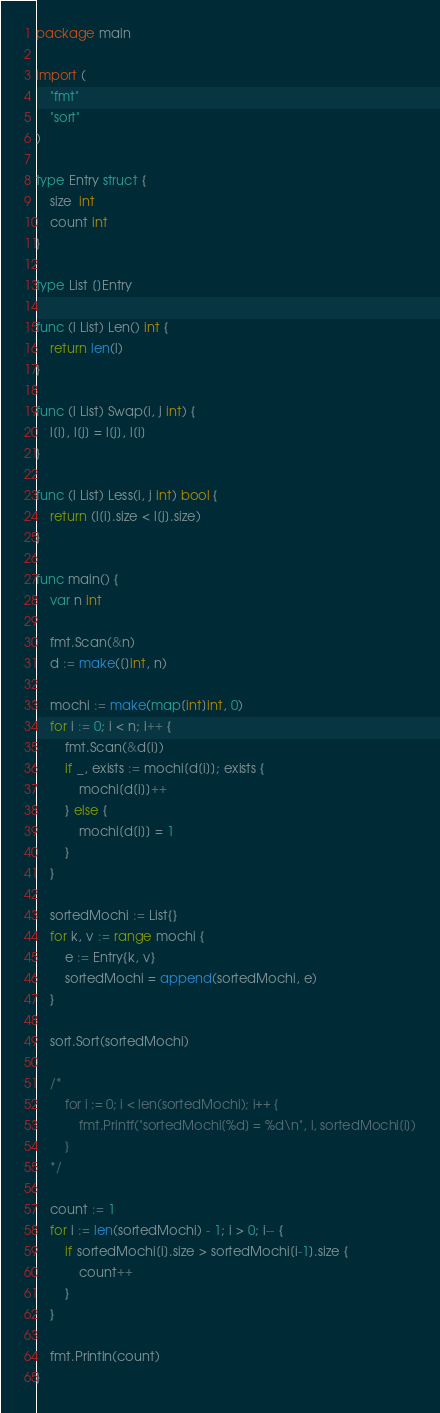Convert code to text. <code><loc_0><loc_0><loc_500><loc_500><_Go_>package main

import (
	"fmt"
	"sort"
)

type Entry struct {
	size  int
	count int
}

type List []Entry

func (l List) Len() int {
	return len(l)
}

func (l List) Swap(i, j int) {
	l[i], l[j] = l[j], l[i]
}

func (l List) Less(i, j int) bool {
	return (l[i].size < l[j].size)
}

func main() {
	var n int

	fmt.Scan(&n)
	d := make([]int, n)

	mochi := make(map[int]int, 0)
	for i := 0; i < n; i++ {
		fmt.Scan(&d[i])
		if _, exists := mochi[d[i]]; exists {
			mochi[d[i]]++
		} else {
			mochi[d[i]] = 1
		}
	}

	sortedMochi := List{}
	for k, v := range mochi {
		e := Entry{k, v}
		sortedMochi = append(sortedMochi, e)
	}

	sort.Sort(sortedMochi)

	/*
		for i := 0; i < len(sortedMochi); i++ {
			fmt.Printf("sortedMochi[%d] = %d\n", i, sortedMochi[i])
		}
	*/

	count := 1
	for i := len(sortedMochi) - 1; i > 0; i-- {
		if sortedMochi[i].size > sortedMochi[i-1].size {
			count++
		}
	}

	fmt.Println(count)
}
</code> 